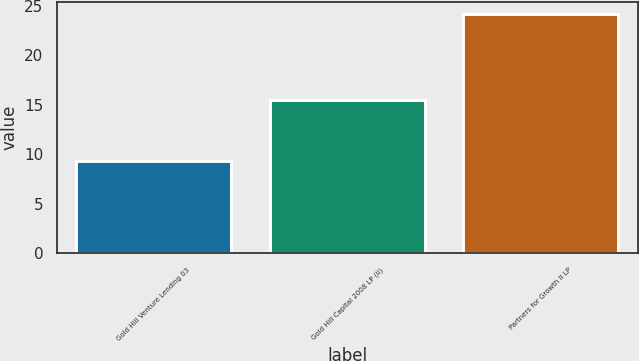Convert chart. <chart><loc_0><loc_0><loc_500><loc_500><bar_chart><fcel>Gold Hill Venture Lending 03<fcel>Gold Hill Capital 2008 LP (ii)<fcel>Partners for Growth II LP<nl><fcel>9.3<fcel>15.5<fcel>24.2<nl></chart> 